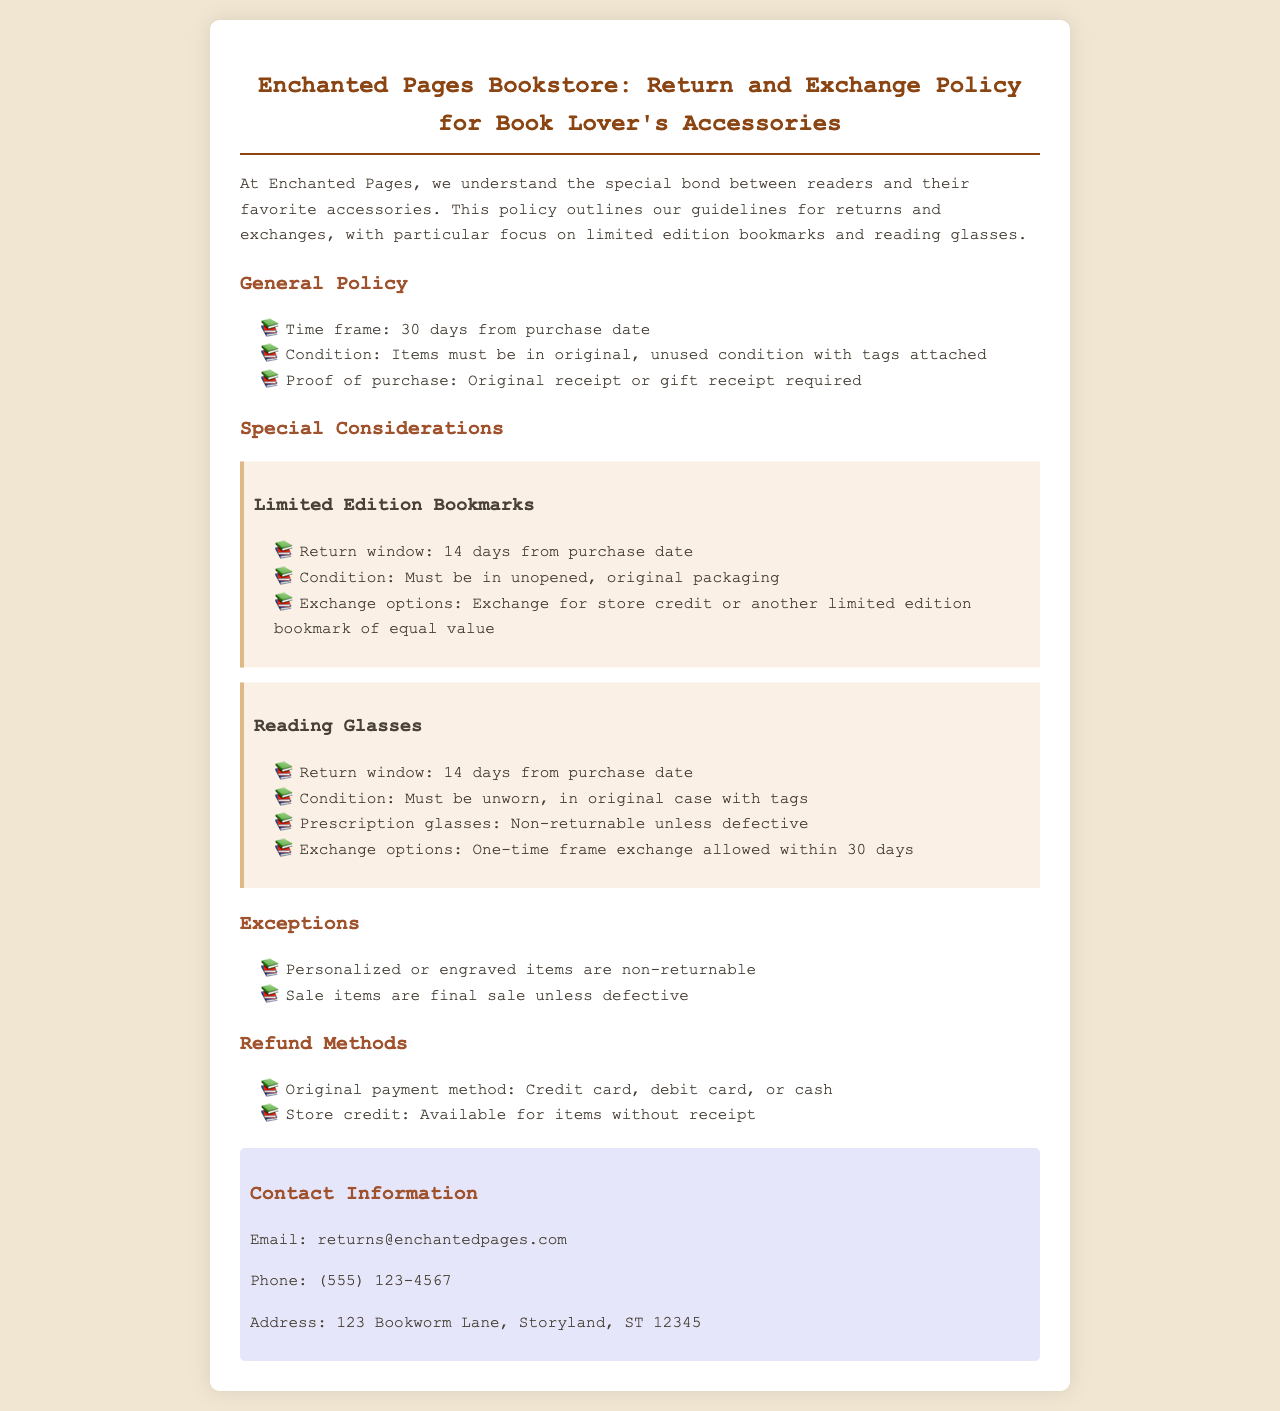What is the return window for limited edition bookmarks? The return window for limited edition bookmarks is specified in the Special Considerations section of the document.
Answer: 14 days What items are non-returnable? Exceptions are listed in the Exceptions section of the policy document.
Answer: Personalized or engraved items What is the required condition for reading glasses to be returned? The condition for returning reading glasses is mentioned in the Reading Glasses section of the document.
Answer: Unworn, in original case with tags What are the exchange options for limited edition bookmarks? The exchange options for limited edition bookmarks are provided in the Limited Edition Bookmarks section.
Answer: Store credit or another limited edition bookmark of equal value How long is the general return policy time frame? The time frame for the general return policy is stated in the General Policy section.
Answer: 30 days What email address should be used for returns inquiries? The contact information for inquiries is listed at the end of the document.
Answer: returns@enchantedpages.com What refund methods are available for items without a receipt? The refund methods available for items without a receipt are discussed in the Refund Methods section.
Answer: Store credit What is the return window for reading glasses? The return window for reading glasses is mentioned in the Special Considerations section of the document.
Answer: 14 days What payment methods are accepted for refunds? The accepted payment methods for refunds are outlined in the Refund Methods section of the document.
Answer: Credit card, debit card, or cash 